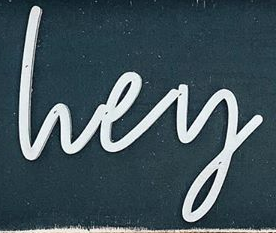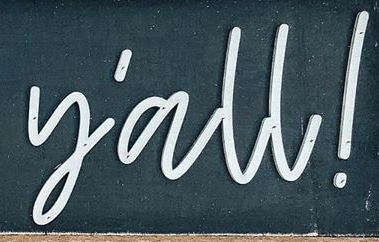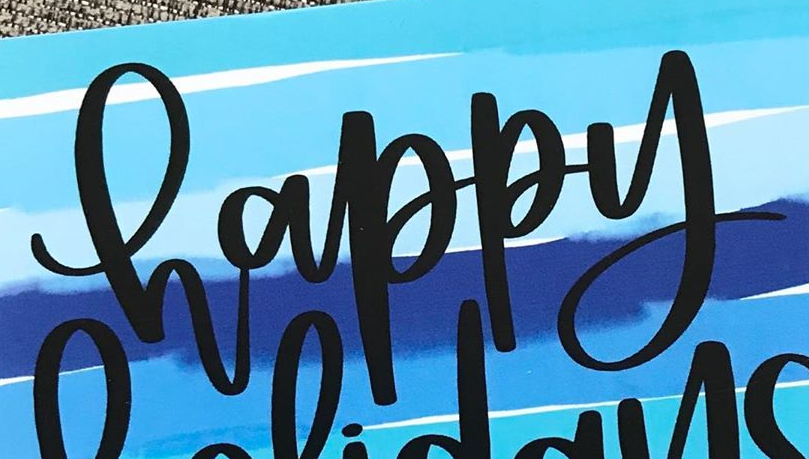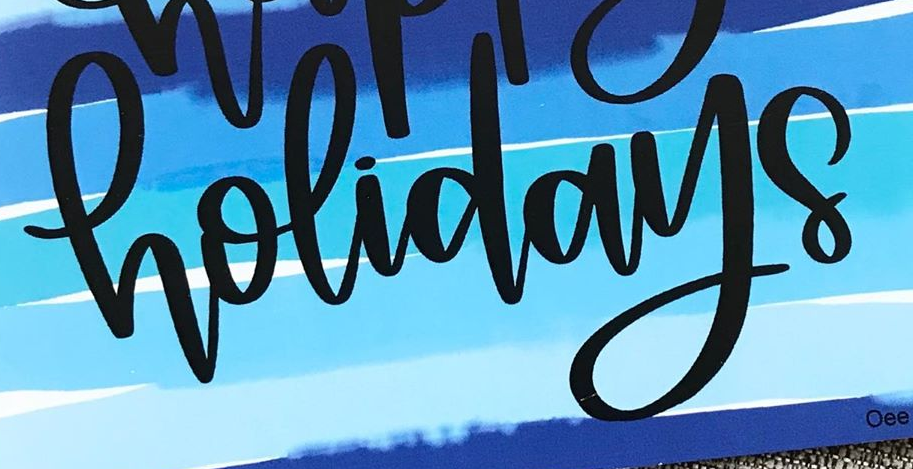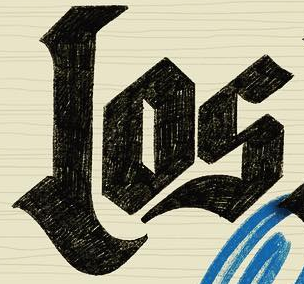Read the text content from these images in order, separated by a semicolon. lvey; y'all!; happy; holidays; Los 